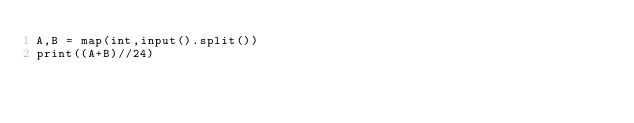<code> <loc_0><loc_0><loc_500><loc_500><_Python_>A,B = map(int,input().split())
print((A+B)//24)</code> 